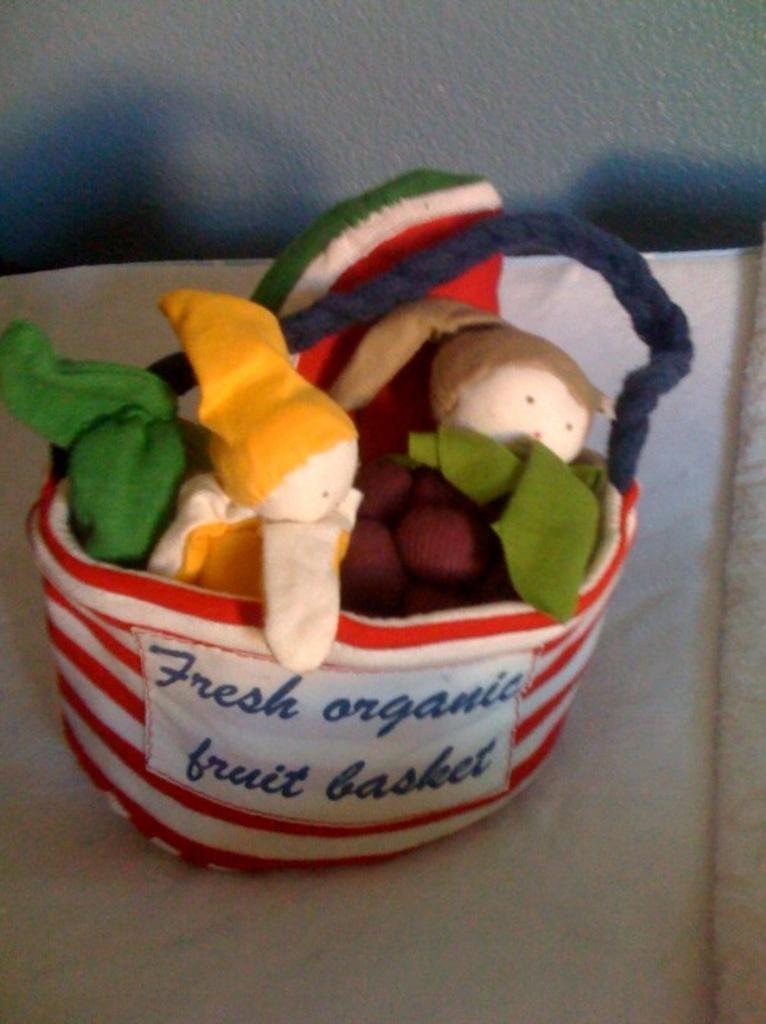How would you summarize this image in a sentence or two? This picture contains a small basket. This basket is in red and white color. In the basket, we see dolls which are in green, yellow and brown color. This basket is placed on the white cloth. In the background, we see a grey color wall. 